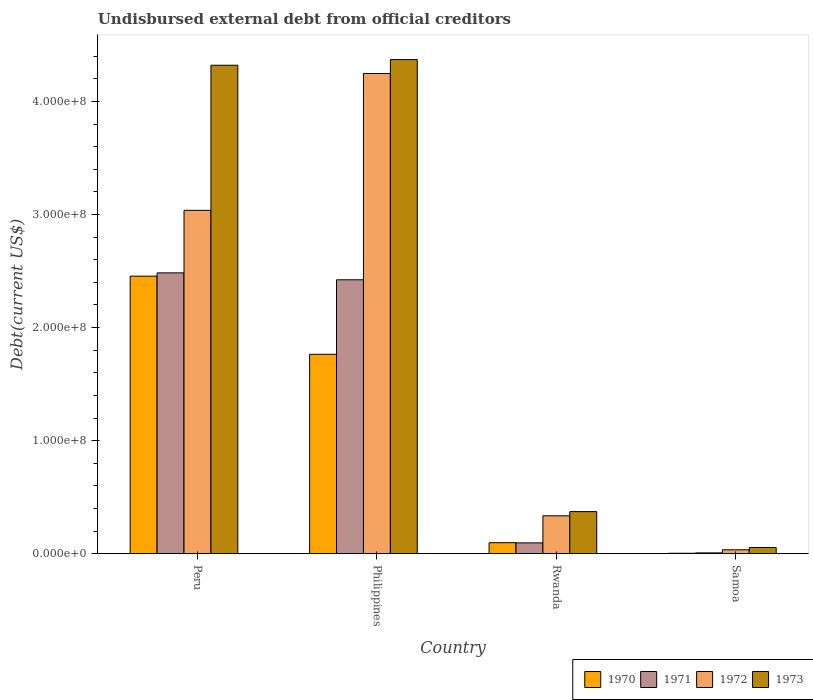Are the number of bars on each tick of the X-axis equal?
Give a very brief answer. Yes. In how many cases, is the number of bars for a given country not equal to the number of legend labels?
Provide a succinct answer. 0. What is the total debt in 1973 in Rwanda?
Offer a terse response. 3.72e+07. Across all countries, what is the maximum total debt in 1973?
Ensure brevity in your answer.  4.37e+08. Across all countries, what is the minimum total debt in 1973?
Make the answer very short. 5.46e+06. In which country was the total debt in 1972 minimum?
Make the answer very short. Samoa. What is the total total debt in 1971 in the graph?
Ensure brevity in your answer.  5.01e+08. What is the difference between the total debt in 1971 in Peru and that in Philippines?
Offer a terse response. 6.12e+06. What is the difference between the total debt in 1970 in Philippines and the total debt in 1973 in Rwanda?
Your answer should be very brief. 1.39e+08. What is the average total debt in 1970 per country?
Provide a succinct answer. 1.08e+08. What is the difference between the total debt of/in 1973 and total debt of/in 1970 in Rwanda?
Your answer should be very brief. 2.75e+07. What is the ratio of the total debt in 1972 in Rwanda to that in Samoa?
Your answer should be very brief. 9.84. What is the difference between the highest and the second highest total debt in 1973?
Give a very brief answer. 5.01e+06. What is the difference between the highest and the lowest total debt in 1971?
Make the answer very short. 2.48e+08. In how many countries, is the total debt in 1970 greater than the average total debt in 1970 taken over all countries?
Provide a succinct answer. 2. Is the sum of the total debt in 1973 in Peru and Samoa greater than the maximum total debt in 1971 across all countries?
Ensure brevity in your answer.  Yes. What does the 2nd bar from the right in Rwanda represents?
Your answer should be very brief. 1972. How many bars are there?
Provide a succinct answer. 16. How many countries are there in the graph?
Provide a short and direct response. 4. Are the values on the major ticks of Y-axis written in scientific E-notation?
Make the answer very short. Yes. Does the graph contain any zero values?
Your response must be concise. No. How many legend labels are there?
Ensure brevity in your answer.  4. How are the legend labels stacked?
Your response must be concise. Horizontal. What is the title of the graph?
Your answer should be very brief. Undisbursed external debt from official creditors. What is the label or title of the X-axis?
Provide a short and direct response. Country. What is the label or title of the Y-axis?
Your answer should be compact. Debt(current US$). What is the Debt(current US$) of 1970 in Peru?
Offer a very short reply. 2.45e+08. What is the Debt(current US$) of 1971 in Peru?
Make the answer very short. 2.48e+08. What is the Debt(current US$) of 1972 in Peru?
Ensure brevity in your answer.  3.04e+08. What is the Debt(current US$) of 1973 in Peru?
Offer a terse response. 4.32e+08. What is the Debt(current US$) of 1970 in Philippines?
Your answer should be very brief. 1.76e+08. What is the Debt(current US$) in 1971 in Philippines?
Your response must be concise. 2.42e+08. What is the Debt(current US$) in 1972 in Philippines?
Provide a short and direct response. 4.25e+08. What is the Debt(current US$) of 1973 in Philippines?
Your response must be concise. 4.37e+08. What is the Debt(current US$) of 1970 in Rwanda?
Your answer should be compact. 9.70e+06. What is the Debt(current US$) of 1971 in Rwanda?
Make the answer very short. 9.53e+06. What is the Debt(current US$) in 1972 in Rwanda?
Provide a succinct answer. 3.35e+07. What is the Debt(current US$) of 1973 in Rwanda?
Your answer should be very brief. 3.72e+07. What is the Debt(current US$) of 1970 in Samoa?
Your answer should be very brief. 3.36e+05. What is the Debt(current US$) in 1971 in Samoa?
Give a very brief answer. 6.88e+05. What is the Debt(current US$) in 1972 in Samoa?
Provide a succinct answer. 3.40e+06. What is the Debt(current US$) of 1973 in Samoa?
Ensure brevity in your answer.  5.46e+06. Across all countries, what is the maximum Debt(current US$) of 1970?
Your answer should be compact. 2.45e+08. Across all countries, what is the maximum Debt(current US$) of 1971?
Provide a short and direct response. 2.48e+08. Across all countries, what is the maximum Debt(current US$) in 1972?
Provide a short and direct response. 4.25e+08. Across all countries, what is the maximum Debt(current US$) in 1973?
Keep it short and to the point. 4.37e+08. Across all countries, what is the minimum Debt(current US$) of 1970?
Your answer should be very brief. 3.36e+05. Across all countries, what is the minimum Debt(current US$) of 1971?
Make the answer very short. 6.88e+05. Across all countries, what is the minimum Debt(current US$) of 1972?
Ensure brevity in your answer.  3.40e+06. Across all countries, what is the minimum Debt(current US$) in 1973?
Your answer should be very brief. 5.46e+06. What is the total Debt(current US$) in 1970 in the graph?
Your answer should be compact. 4.32e+08. What is the total Debt(current US$) of 1971 in the graph?
Ensure brevity in your answer.  5.01e+08. What is the total Debt(current US$) of 1972 in the graph?
Ensure brevity in your answer.  7.65e+08. What is the total Debt(current US$) of 1973 in the graph?
Make the answer very short. 9.12e+08. What is the difference between the Debt(current US$) in 1970 in Peru and that in Philippines?
Make the answer very short. 6.91e+07. What is the difference between the Debt(current US$) in 1971 in Peru and that in Philippines?
Your answer should be very brief. 6.12e+06. What is the difference between the Debt(current US$) in 1972 in Peru and that in Philippines?
Give a very brief answer. -1.21e+08. What is the difference between the Debt(current US$) in 1973 in Peru and that in Philippines?
Your answer should be compact. -5.01e+06. What is the difference between the Debt(current US$) in 1970 in Peru and that in Rwanda?
Your response must be concise. 2.36e+08. What is the difference between the Debt(current US$) of 1971 in Peru and that in Rwanda?
Your answer should be compact. 2.39e+08. What is the difference between the Debt(current US$) of 1972 in Peru and that in Rwanda?
Keep it short and to the point. 2.70e+08. What is the difference between the Debt(current US$) of 1973 in Peru and that in Rwanda?
Offer a very short reply. 3.95e+08. What is the difference between the Debt(current US$) in 1970 in Peru and that in Samoa?
Your answer should be very brief. 2.45e+08. What is the difference between the Debt(current US$) of 1971 in Peru and that in Samoa?
Your answer should be compact. 2.48e+08. What is the difference between the Debt(current US$) of 1972 in Peru and that in Samoa?
Keep it short and to the point. 3.00e+08. What is the difference between the Debt(current US$) of 1973 in Peru and that in Samoa?
Provide a succinct answer. 4.27e+08. What is the difference between the Debt(current US$) in 1970 in Philippines and that in Rwanda?
Give a very brief answer. 1.67e+08. What is the difference between the Debt(current US$) in 1971 in Philippines and that in Rwanda?
Ensure brevity in your answer.  2.33e+08. What is the difference between the Debt(current US$) in 1972 in Philippines and that in Rwanda?
Ensure brevity in your answer.  3.91e+08. What is the difference between the Debt(current US$) of 1973 in Philippines and that in Rwanda?
Provide a short and direct response. 4.00e+08. What is the difference between the Debt(current US$) of 1970 in Philippines and that in Samoa?
Make the answer very short. 1.76e+08. What is the difference between the Debt(current US$) in 1971 in Philippines and that in Samoa?
Provide a short and direct response. 2.42e+08. What is the difference between the Debt(current US$) in 1972 in Philippines and that in Samoa?
Give a very brief answer. 4.21e+08. What is the difference between the Debt(current US$) of 1973 in Philippines and that in Samoa?
Offer a very short reply. 4.32e+08. What is the difference between the Debt(current US$) in 1970 in Rwanda and that in Samoa?
Your answer should be compact. 9.36e+06. What is the difference between the Debt(current US$) of 1971 in Rwanda and that in Samoa?
Keep it short and to the point. 8.84e+06. What is the difference between the Debt(current US$) of 1972 in Rwanda and that in Samoa?
Give a very brief answer. 3.01e+07. What is the difference between the Debt(current US$) of 1973 in Rwanda and that in Samoa?
Provide a succinct answer. 3.17e+07. What is the difference between the Debt(current US$) of 1970 in Peru and the Debt(current US$) of 1971 in Philippines?
Offer a terse response. 3.20e+06. What is the difference between the Debt(current US$) of 1970 in Peru and the Debt(current US$) of 1972 in Philippines?
Offer a very short reply. -1.79e+08. What is the difference between the Debt(current US$) of 1970 in Peru and the Debt(current US$) of 1973 in Philippines?
Offer a terse response. -1.92e+08. What is the difference between the Debt(current US$) of 1971 in Peru and the Debt(current US$) of 1972 in Philippines?
Make the answer very short. -1.76e+08. What is the difference between the Debt(current US$) in 1971 in Peru and the Debt(current US$) in 1973 in Philippines?
Keep it short and to the point. -1.89e+08. What is the difference between the Debt(current US$) in 1972 in Peru and the Debt(current US$) in 1973 in Philippines?
Offer a terse response. -1.33e+08. What is the difference between the Debt(current US$) in 1970 in Peru and the Debt(current US$) in 1971 in Rwanda?
Your response must be concise. 2.36e+08. What is the difference between the Debt(current US$) in 1970 in Peru and the Debt(current US$) in 1972 in Rwanda?
Offer a very short reply. 2.12e+08. What is the difference between the Debt(current US$) of 1970 in Peru and the Debt(current US$) of 1973 in Rwanda?
Keep it short and to the point. 2.08e+08. What is the difference between the Debt(current US$) in 1971 in Peru and the Debt(current US$) in 1972 in Rwanda?
Provide a short and direct response. 2.15e+08. What is the difference between the Debt(current US$) in 1971 in Peru and the Debt(current US$) in 1973 in Rwanda?
Offer a terse response. 2.11e+08. What is the difference between the Debt(current US$) in 1972 in Peru and the Debt(current US$) in 1973 in Rwanda?
Give a very brief answer. 2.67e+08. What is the difference between the Debt(current US$) in 1970 in Peru and the Debt(current US$) in 1971 in Samoa?
Make the answer very short. 2.45e+08. What is the difference between the Debt(current US$) of 1970 in Peru and the Debt(current US$) of 1972 in Samoa?
Give a very brief answer. 2.42e+08. What is the difference between the Debt(current US$) of 1970 in Peru and the Debt(current US$) of 1973 in Samoa?
Give a very brief answer. 2.40e+08. What is the difference between the Debt(current US$) in 1971 in Peru and the Debt(current US$) in 1972 in Samoa?
Keep it short and to the point. 2.45e+08. What is the difference between the Debt(current US$) in 1971 in Peru and the Debt(current US$) in 1973 in Samoa?
Ensure brevity in your answer.  2.43e+08. What is the difference between the Debt(current US$) of 1972 in Peru and the Debt(current US$) of 1973 in Samoa?
Your answer should be compact. 2.98e+08. What is the difference between the Debt(current US$) of 1970 in Philippines and the Debt(current US$) of 1971 in Rwanda?
Your answer should be compact. 1.67e+08. What is the difference between the Debt(current US$) in 1970 in Philippines and the Debt(current US$) in 1972 in Rwanda?
Offer a very short reply. 1.43e+08. What is the difference between the Debt(current US$) of 1970 in Philippines and the Debt(current US$) of 1973 in Rwanda?
Offer a terse response. 1.39e+08. What is the difference between the Debt(current US$) of 1971 in Philippines and the Debt(current US$) of 1972 in Rwanda?
Your answer should be compact. 2.09e+08. What is the difference between the Debt(current US$) in 1971 in Philippines and the Debt(current US$) in 1973 in Rwanda?
Provide a succinct answer. 2.05e+08. What is the difference between the Debt(current US$) of 1972 in Philippines and the Debt(current US$) of 1973 in Rwanda?
Provide a short and direct response. 3.88e+08. What is the difference between the Debt(current US$) of 1970 in Philippines and the Debt(current US$) of 1971 in Samoa?
Make the answer very short. 1.76e+08. What is the difference between the Debt(current US$) of 1970 in Philippines and the Debt(current US$) of 1972 in Samoa?
Give a very brief answer. 1.73e+08. What is the difference between the Debt(current US$) in 1970 in Philippines and the Debt(current US$) in 1973 in Samoa?
Keep it short and to the point. 1.71e+08. What is the difference between the Debt(current US$) in 1971 in Philippines and the Debt(current US$) in 1972 in Samoa?
Your response must be concise. 2.39e+08. What is the difference between the Debt(current US$) of 1971 in Philippines and the Debt(current US$) of 1973 in Samoa?
Offer a very short reply. 2.37e+08. What is the difference between the Debt(current US$) in 1972 in Philippines and the Debt(current US$) in 1973 in Samoa?
Provide a succinct answer. 4.19e+08. What is the difference between the Debt(current US$) in 1970 in Rwanda and the Debt(current US$) in 1971 in Samoa?
Keep it short and to the point. 9.01e+06. What is the difference between the Debt(current US$) of 1970 in Rwanda and the Debt(current US$) of 1972 in Samoa?
Ensure brevity in your answer.  6.29e+06. What is the difference between the Debt(current US$) in 1970 in Rwanda and the Debt(current US$) in 1973 in Samoa?
Your answer should be compact. 4.23e+06. What is the difference between the Debt(current US$) in 1971 in Rwanda and the Debt(current US$) in 1972 in Samoa?
Ensure brevity in your answer.  6.13e+06. What is the difference between the Debt(current US$) of 1971 in Rwanda and the Debt(current US$) of 1973 in Samoa?
Offer a very short reply. 4.07e+06. What is the difference between the Debt(current US$) of 1972 in Rwanda and the Debt(current US$) of 1973 in Samoa?
Give a very brief answer. 2.80e+07. What is the average Debt(current US$) in 1970 per country?
Make the answer very short. 1.08e+08. What is the average Debt(current US$) of 1971 per country?
Your answer should be very brief. 1.25e+08. What is the average Debt(current US$) of 1972 per country?
Your answer should be very brief. 1.91e+08. What is the average Debt(current US$) in 1973 per country?
Give a very brief answer. 2.28e+08. What is the difference between the Debt(current US$) of 1970 and Debt(current US$) of 1971 in Peru?
Provide a succinct answer. -2.92e+06. What is the difference between the Debt(current US$) in 1970 and Debt(current US$) in 1972 in Peru?
Your answer should be compact. -5.82e+07. What is the difference between the Debt(current US$) in 1970 and Debt(current US$) in 1973 in Peru?
Provide a succinct answer. -1.87e+08. What is the difference between the Debt(current US$) of 1971 and Debt(current US$) of 1972 in Peru?
Your answer should be very brief. -5.53e+07. What is the difference between the Debt(current US$) in 1971 and Debt(current US$) in 1973 in Peru?
Keep it short and to the point. -1.84e+08. What is the difference between the Debt(current US$) of 1972 and Debt(current US$) of 1973 in Peru?
Your answer should be very brief. -1.28e+08. What is the difference between the Debt(current US$) of 1970 and Debt(current US$) of 1971 in Philippines?
Your response must be concise. -6.59e+07. What is the difference between the Debt(current US$) of 1970 and Debt(current US$) of 1972 in Philippines?
Your answer should be very brief. -2.48e+08. What is the difference between the Debt(current US$) of 1970 and Debt(current US$) of 1973 in Philippines?
Make the answer very short. -2.61e+08. What is the difference between the Debt(current US$) in 1971 and Debt(current US$) in 1972 in Philippines?
Make the answer very short. -1.83e+08. What is the difference between the Debt(current US$) of 1971 and Debt(current US$) of 1973 in Philippines?
Give a very brief answer. -1.95e+08. What is the difference between the Debt(current US$) in 1972 and Debt(current US$) in 1973 in Philippines?
Provide a succinct answer. -1.23e+07. What is the difference between the Debt(current US$) in 1970 and Debt(current US$) in 1971 in Rwanda?
Ensure brevity in your answer.  1.63e+05. What is the difference between the Debt(current US$) in 1970 and Debt(current US$) in 1972 in Rwanda?
Make the answer very short. -2.38e+07. What is the difference between the Debt(current US$) in 1970 and Debt(current US$) in 1973 in Rwanda?
Provide a succinct answer. -2.75e+07. What is the difference between the Debt(current US$) of 1971 and Debt(current US$) of 1972 in Rwanda?
Your answer should be very brief. -2.40e+07. What is the difference between the Debt(current US$) of 1971 and Debt(current US$) of 1973 in Rwanda?
Your answer should be compact. -2.77e+07. What is the difference between the Debt(current US$) in 1972 and Debt(current US$) in 1973 in Rwanda?
Offer a terse response. -3.72e+06. What is the difference between the Debt(current US$) in 1970 and Debt(current US$) in 1971 in Samoa?
Make the answer very short. -3.52e+05. What is the difference between the Debt(current US$) in 1970 and Debt(current US$) in 1972 in Samoa?
Give a very brief answer. -3.07e+06. What is the difference between the Debt(current US$) of 1970 and Debt(current US$) of 1973 in Samoa?
Offer a very short reply. -5.13e+06. What is the difference between the Debt(current US$) in 1971 and Debt(current US$) in 1972 in Samoa?
Give a very brief answer. -2.72e+06. What is the difference between the Debt(current US$) in 1971 and Debt(current US$) in 1973 in Samoa?
Make the answer very short. -4.77e+06. What is the difference between the Debt(current US$) of 1972 and Debt(current US$) of 1973 in Samoa?
Offer a very short reply. -2.06e+06. What is the ratio of the Debt(current US$) in 1970 in Peru to that in Philippines?
Offer a terse response. 1.39. What is the ratio of the Debt(current US$) in 1971 in Peru to that in Philippines?
Provide a short and direct response. 1.03. What is the ratio of the Debt(current US$) of 1972 in Peru to that in Philippines?
Provide a succinct answer. 0.71. What is the ratio of the Debt(current US$) in 1973 in Peru to that in Philippines?
Offer a very short reply. 0.99. What is the ratio of the Debt(current US$) of 1970 in Peru to that in Rwanda?
Offer a very short reply. 25.32. What is the ratio of the Debt(current US$) of 1971 in Peru to that in Rwanda?
Ensure brevity in your answer.  26.06. What is the ratio of the Debt(current US$) in 1972 in Peru to that in Rwanda?
Your answer should be very brief. 9.07. What is the ratio of the Debt(current US$) in 1973 in Peru to that in Rwanda?
Provide a succinct answer. 11.61. What is the ratio of the Debt(current US$) of 1970 in Peru to that in Samoa?
Offer a very short reply. 730.63. What is the ratio of the Debt(current US$) in 1971 in Peru to that in Samoa?
Provide a succinct answer. 361.06. What is the ratio of the Debt(current US$) in 1972 in Peru to that in Samoa?
Offer a very short reply. 89.2. What is the ratio of the Debt(current US$) of 1973 in Peru to that in Samoa?
Keep it short and to the point. 79.11. What is the ratio of the Debt(current US$) of 1970 in Philippines to that in Rwanda?
Make the answer very short. 18.19. What is the ratio of the Debt(current US$) of 1971 in Philippines to that in Rwanda?
Make the answer very short. 25.42. What is the ratio of the Debt(current US$) of 1972 in Philippines to that in Rwanda?
Your answer should be very brief. 12.68. What is the ratio of the Debt(current US$) of 1973 in Philippines to that in Rwanda?
Give a very brief answer. 11.75. What is the ratio of the Debt(current US$) in 1970 in Philippines to that in Samoa?
Provide a succinct answer. 524.93. What is the ratio of the Debt(current US$) of 1971 in Philippines to that in Samoa?
Provide a short and direct response. 352.16. What is the ratio of the Debt(current US$) of 1972 in Philippines to that in Samoa?
Give a very brief answer. 124.76. What is the ratio of the Debt(current US$) of 1973 in Philippines to that in Samoa?
Give a very brief answer. 80.03. What is the ratio of the Debt(current US$) of 1970 in Rwanda to that in Samoa?
Make the answer very short. 28.86. What is the ratio of the Debt(current US$) of 1971 in Rwanda to that in Samoa?
Your answer should be compact. 13.86. What is the ratio of the Debt(current US$) of 1972 in Rwanda to that in Samoa?
Keep it short and to the point. 9.84. What is the ratio of the Debt(current US$) of 1973 in Rwanda to that in Samoa?
Ensure brevity in your answer.  6.81. What is the difference between the highest and the second highest Debt(current US$) of 1970?
Keep it short and to the point. 6.91e+07. What is the difference between the highest and the second highest Debt(current US$) of 1971?
Your answer should be very brief. 6.12e+06. What is the difference between the highest and the second highest Debt(current US$) of 1972?
Give a very brief answer. 1.21e+08. What is the difference between the highest and the second highest Debt(current US$) in 1973?
Your response must be concise. 5.01e+06. What is the difference between the highest and the lowest Debt(current US$) of 1970?
Provide a short and direct response. 2.45e+08. What is the difference between the highest and the lowest Debt(current US$) in 1971?
Keep it short and to the point. 2.48e+08. What is the difference between the highest and the lowest Debt(current US$) in 1972?
Provide a short and direct response. 4.21e+08. What is the difference between the highest and the lowest Debt(current US$) of 1973?
Provide a succinct answer. 4.32e+08. 